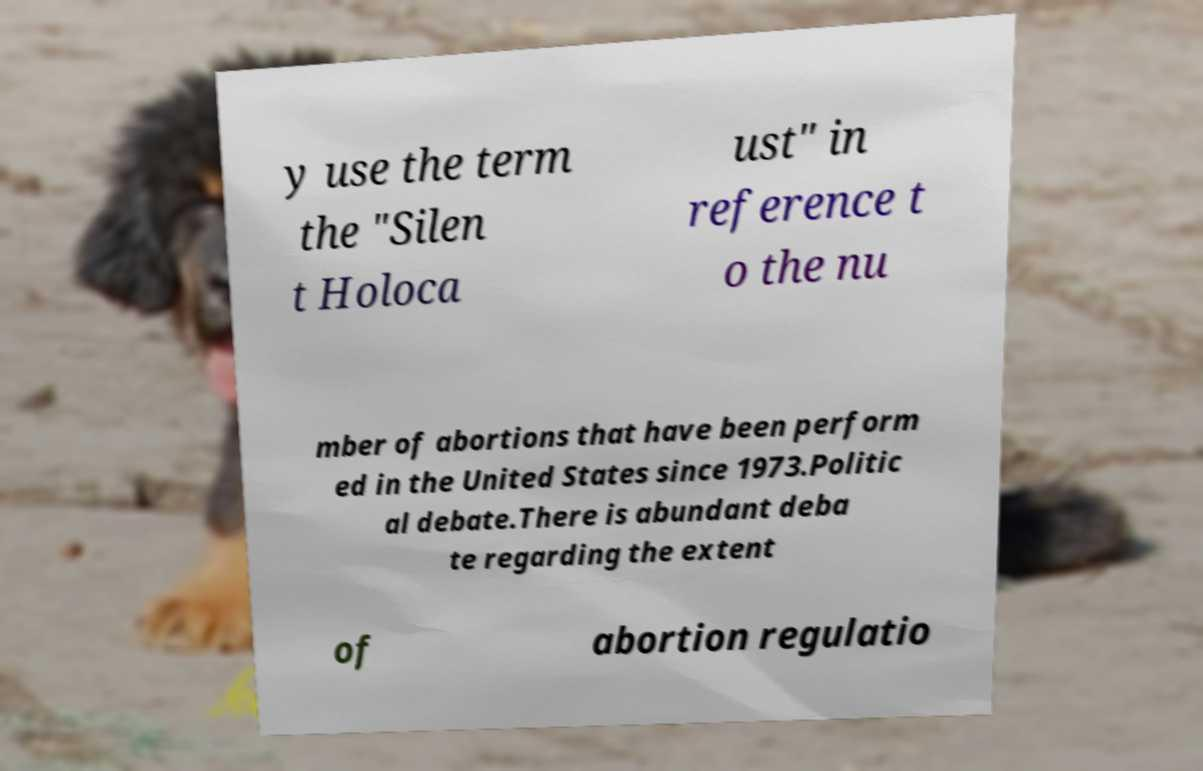Could you extract and type out the text from this image? y use the term the "Silen t Holoca ust" in reference t o the nu mber of abortions that have been perform ed in the United States since 1973.Politic al debate.There is abundant deba te regarding the extent of abortion regulatio 